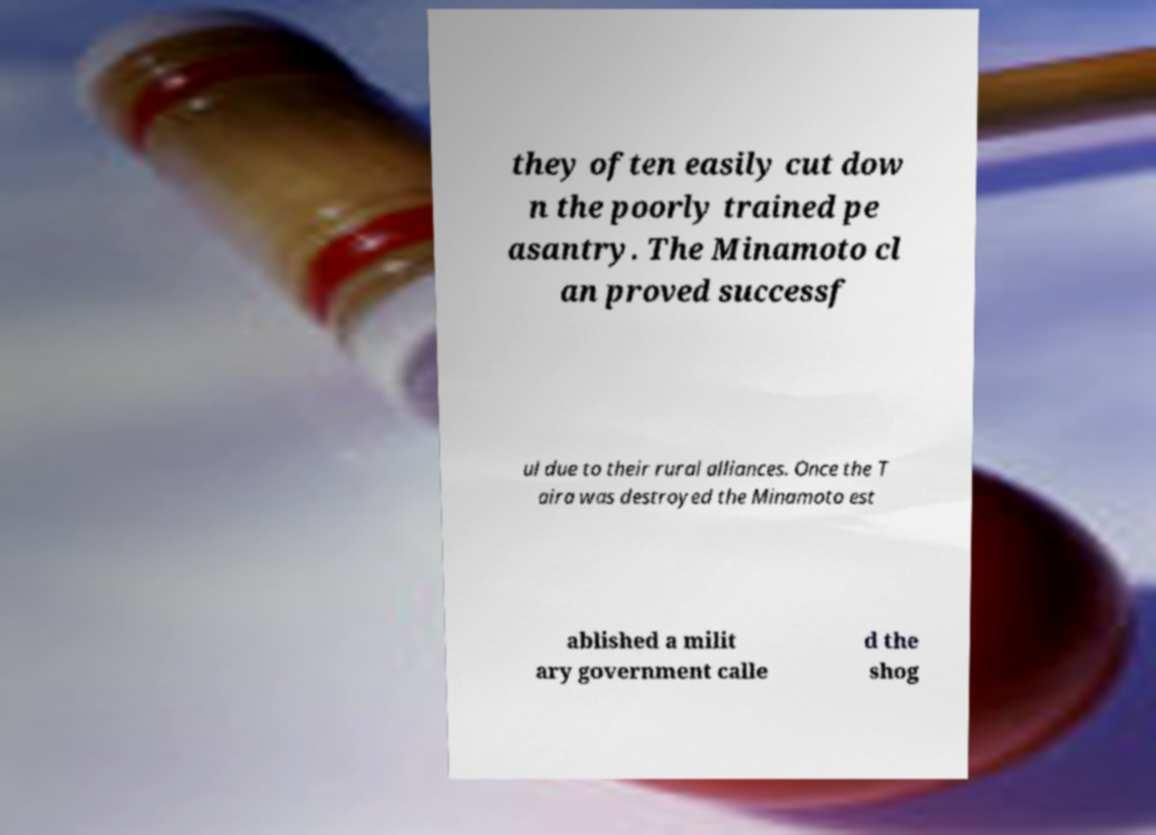What messages or text are displayed in this image? I need them in a readable, typed format. they often easily cut dow n the poorly trained pe asantry. The Minamoto cl an proved successf ul due to their rural alliances. Once the T aira was destroyed the Minamoto est ablished a milit ary government calle d the shog 